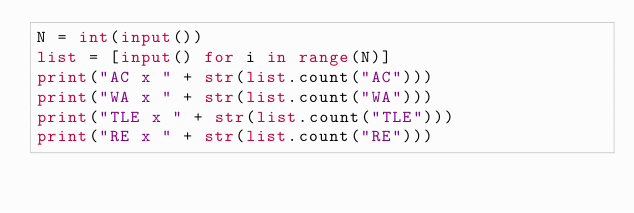<code> <loc_0><loc_0><loc_500><loc_500><_Python_>N = int(input())
list = [input() for i in range(N)]
print("AC x " + str(list.count("AC")))
print("WA x " + str(list.count("WA"))) 
print("TLE x " + str(list.count("TLE")))
print("RE x " + str(list.count("RE")))        </code> 